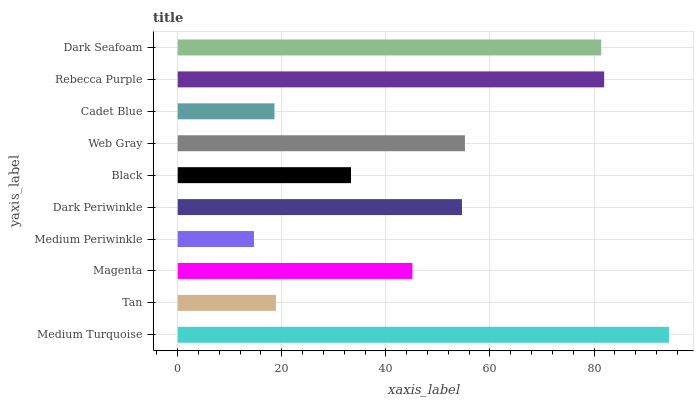Is Medium Periwinkle the minimum?
Answer yes or no. Yes. Is Medium Turquoise the maximum?
Answer yes or no. Yes. Is Tan the minimum?
Answer yes or no. No. Is Tan the maximum?
Answer yes or no. No. Is Medium Turquoise greater than Tan?
Answer yes or no. Yes. Is Tan less than Medium Turquoise?
Answer yes or no. Yes. Is Tan greater than Medium Turquoise?
Answer yes or no. No. Is Medium Turquoise less than Tan?
Answer yes or no. No. Is Dark Periwinkle the high median?
Answer yes or no. Yes. Is Magenta the low median?
Answer yes or no. Yes. Is Black the high median?
Answer yes or no. No. Is Web Gray the low median?
Answer yes or no. No. 